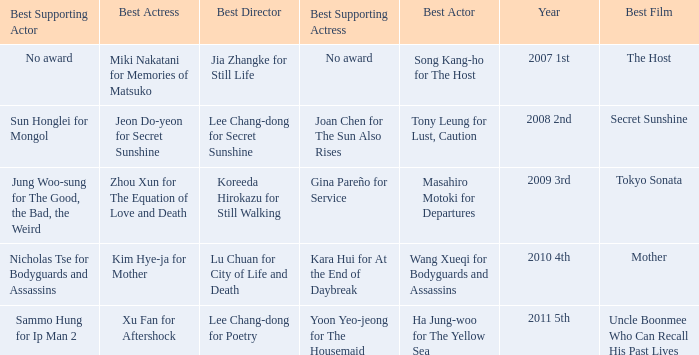Name the best actor for uncle boonmee who can recall his past lives Ha Jung-woo for The Yellow Sea. 